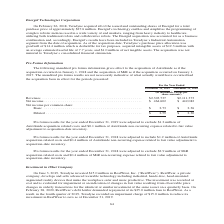According to Teradyne's financial document, What were the Pro forma results for the year ended December 31, 2019 adjusted for? adjusted to exclude $1.2 million of AutoGuide acquisition related costs and $0.1 million of AutoGuide non-recurring expense related to fair value adjustment to acquisition-date inventory.. The document states: "results for the year ended December 31, 2019 were adjusted to exclude $1.2 million of AutoGuide acquisition related costs and $0.1 million of AutoGuid..." Also, What was the net income in 2019? According to the financial document, $464,602 (in thousands). The relevant text states: ") Revenues . $2,303,737 $2,111,373 Net income . $ 464,602 $ 442,082 Net income per common share: Basic . $ 2.73 $ 2.36..." Also, What are the types of net income per common share in the table? The document shows two values: Basic and Diluted. From the document: "Diluted . $ 2.59 $ 2.30 $ 464,602 $ 442,082 Net income per common share: Basic . $ 2.73 $ 2.36..." Additionally, In which year was diluted net income per common share larger? According to the financial document, 2019. The relevant text states: "December 31, 2019 December 31, 2018..." Also, can you calculate: What was the change in diluted net income per common share from 2018 to 2019? Based on the calculation: 2.59-2.30, the result is 0.29. This is based on the information: "Diluted . $ 2.59 $ 2.30 Diluted . $ 2.59 $ 2.30..." The key data points involved are: 2.30, 2.59. Also, can you calculate: What was the percentage change in diluted net income per common share from 2018 to 2019? To answer this question, I need to perform calculations using the financial data. The calculation is: (2.59-2.30)/2.30, which equals 12.61 (percentage). This is based on the information: "Diluted . $ 2.59 $ 2.30 Diluted . $ 2.59 $ 2.30..." The key data points involved are: 2.30, 2.59. 